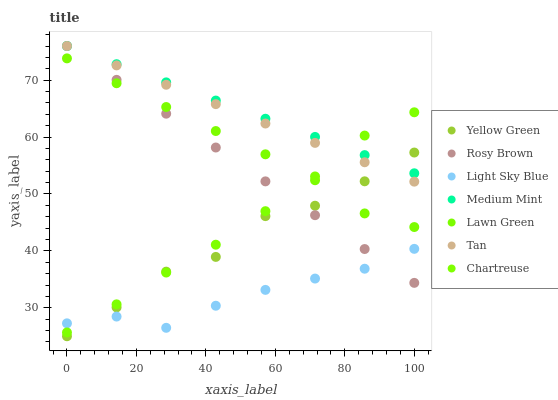Does Light Sky Blue have the minimum area under the curve?
Answer yes or no. Yes. Does Medium Mint have the maximum area under the curve?
Answer yes or no. Yes. Does Lawn Green have the minimum area under the curve?
Answer yes or no. No. Does Lawn Green have the maximum area under the curve?
Answer yes or no. No. Is Tan the smoothest?
Answer yes or no. Yes. Is Yellow Green the roughest?
Answer yes or no. Yes. Is Lawn Green the smoothest?
Answer yes or no. No. Is Lawn Green the roughest?
Answer yes or no. No. Does Yellow Green have the lowest value?
Answer yes or no. Yes. Does Lawn Green have the lowest value?
Answer yes or no. No. Does Tan have the highest value?
Answer yes or no. Yes. Does Lawn Green have the highest value?
Answer yes or no. No. Is Lawn Green less than Tan?
Answer yes or no. Yes. Is Tan greater than Light Sky Blue?
Answer yes or no. Yes. Does Chartreuse intersect Rosy Brown?
Answer yes or no. Yes. Is Chartreuse less than Rosy Brown?
Answer yes or no. No. Is Chartreuse greater than Rosy Brown?
Answer yes or no. No. Does Lawn Green intersect Tan?
Answer yes or no. No. 